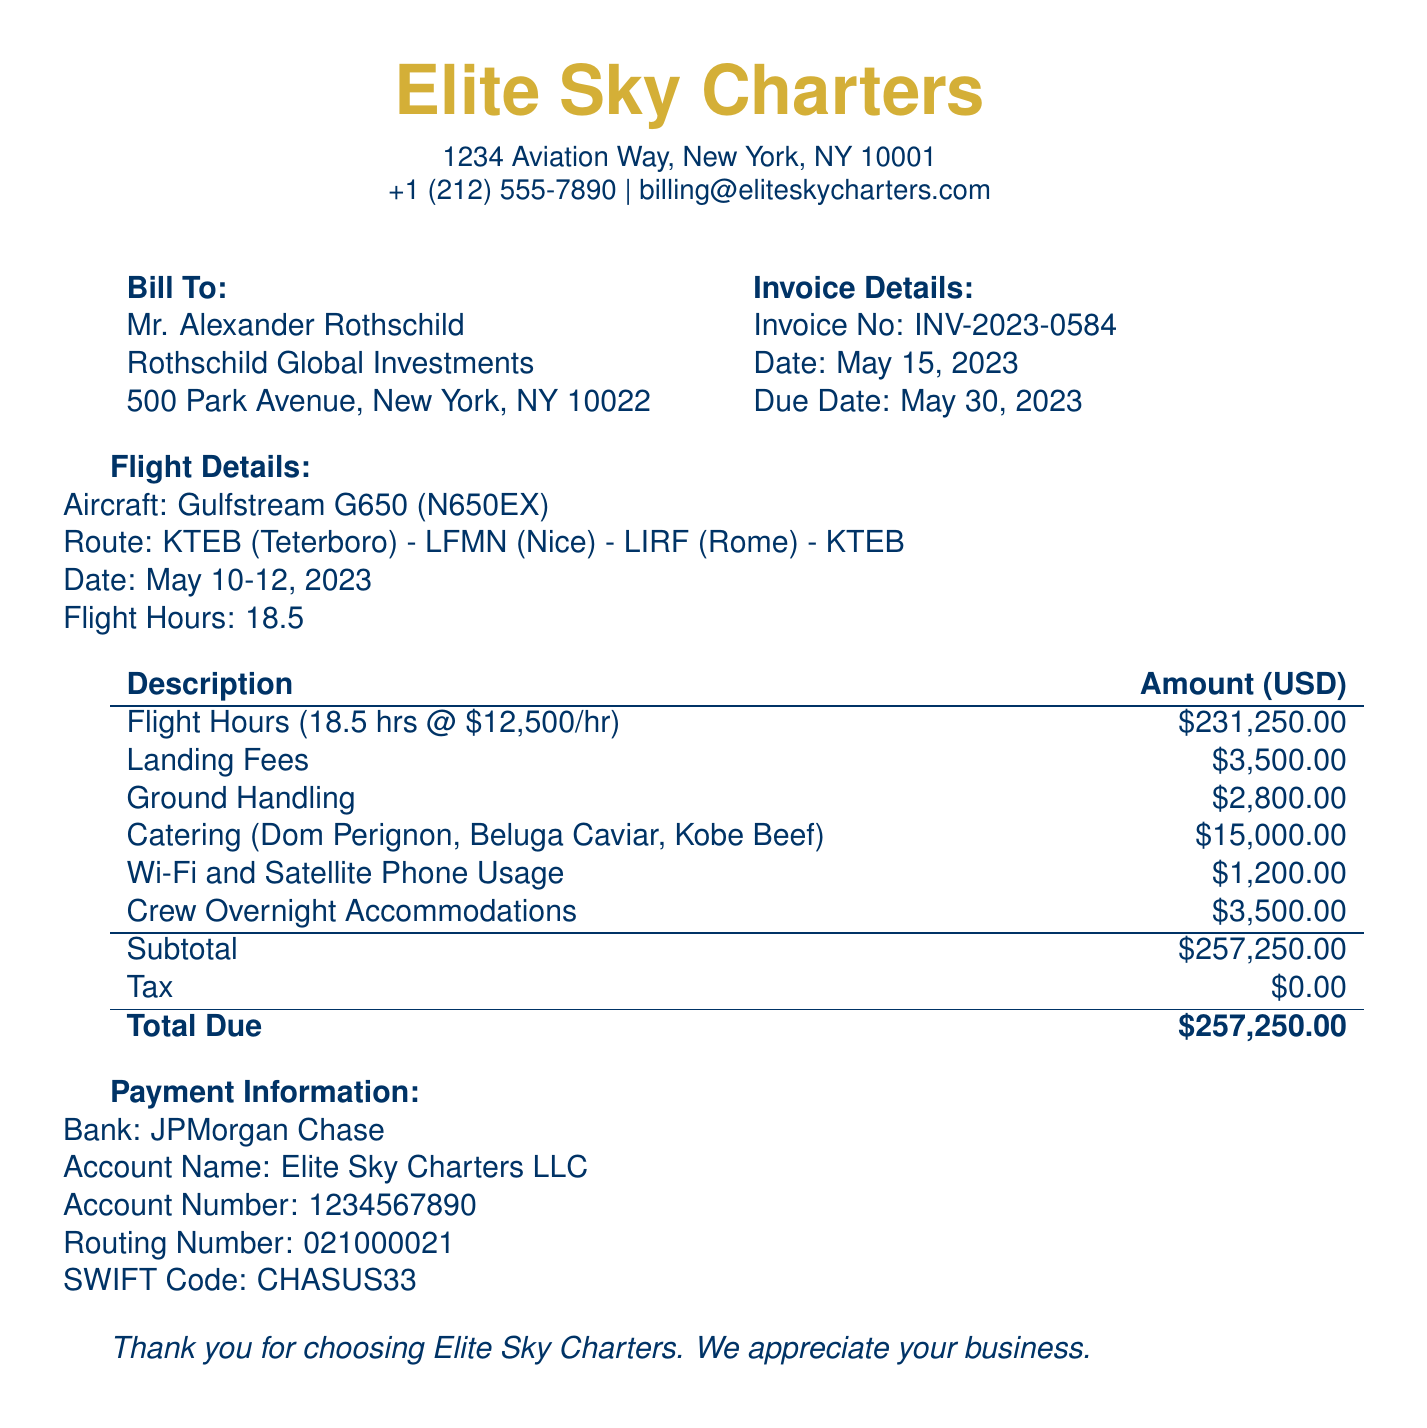what is the total due amount? The total due amount is clearly stated at the end of the billing document.
Answer: $257,250.00 what is the invoice number? The invoice number is specified at the beginning of the invoice details section.
Answer: INV-2023-0584 what is the date of the invoice? The date of the invoice is provided in the invoice details section.
Answer: May 15, 2023 how many flight hours were billed? The total flight hours are detailed under flight details in the document.
Answer: 18.5 what is the landing fee amount? The landing fee is listed in the description of charges.
Answer: $3,500.00 what was the route for the flight? The flight route is specified in the flight details section of the document.
Answer: KTEB - LFMN - LIRF - KTEB how much was spent on catering? The total amount for catering is detailed in the table of charges.
Answer: $15,000.00 who is the bill addressed to? The individual that the bill is addressed to is found in the bill to section.
Answer: Mr. Alexander Rothschild what is the due date for payment? The due date for payment is specified in the invoice details.
Answer: May 30, 2023 